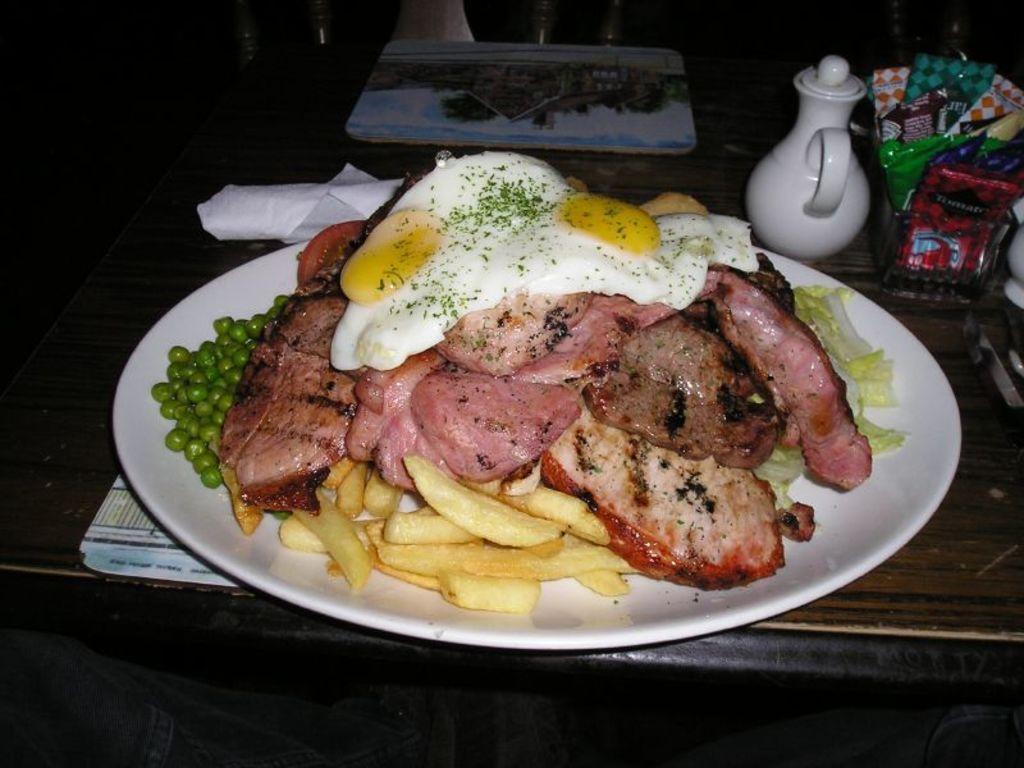How would you summarize this image in a sentence or two? In this picture I can see food items on the plate. I can see table mats, jug and some other items on the table, and in the background there are some objects. 